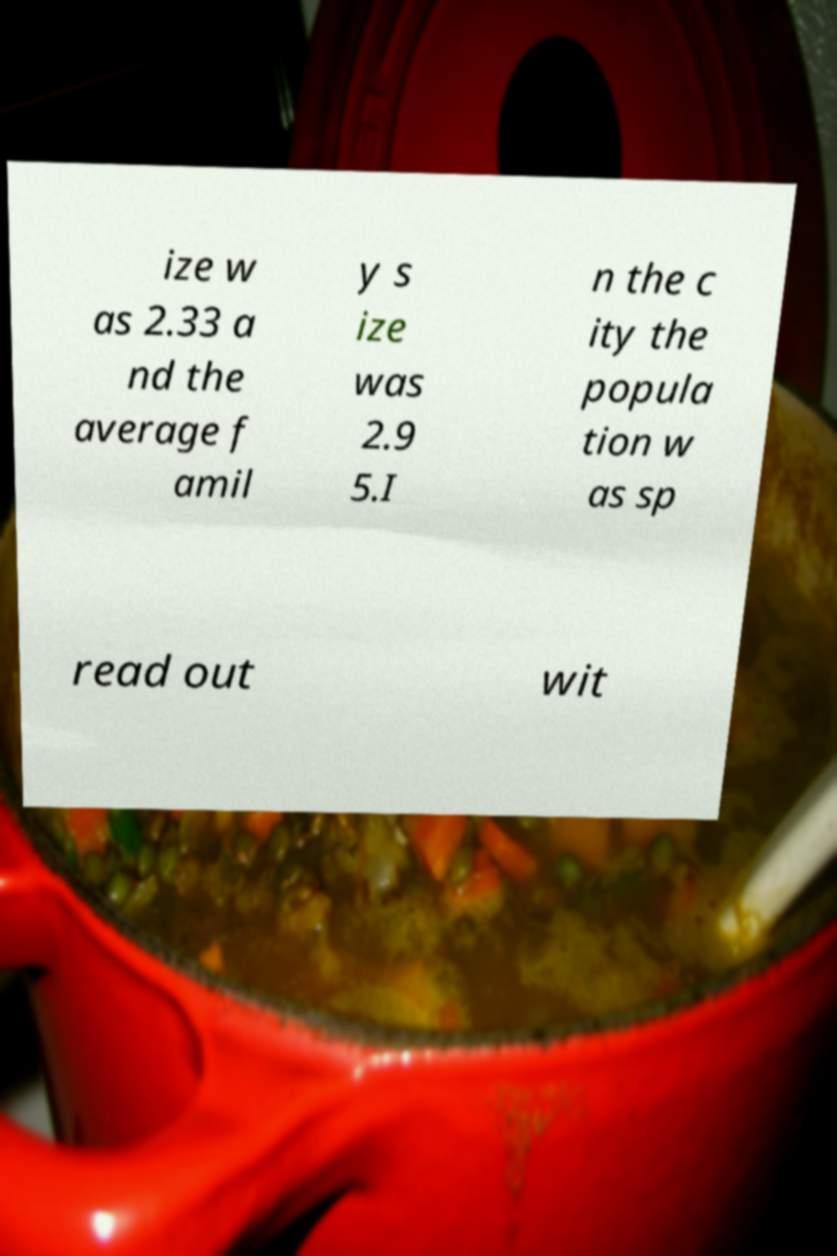Could you extract and type out the text from this image? ize w as 2.33 a nd the average f amil y s ize was 2.9 5.I n the c ity the popula tion w as sp read out wit 